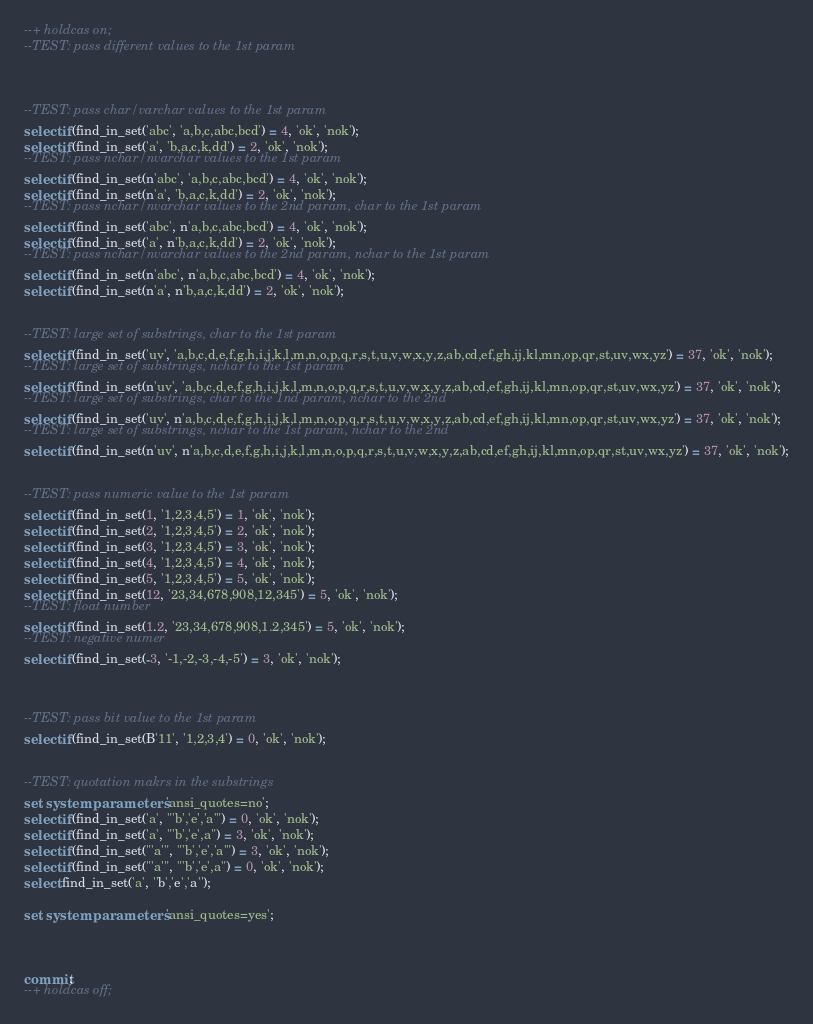Convert code to text. <code><loc_0><loc_0><loc_500><loc_500><_SQL_>--+ holdcas on;
--TEST: pass different values to the 1st param



--TEST: pass char/varchar values to the 1st param
select if(find_in_set('abc', 'a,b,c,abc,bcd') = 4, 'ok', 'nok');
select if(find_in_set('a', 'b,a,c,k,dd') = 2, 'ok', 'nok');
--TEST: pass nchar/nvarchar values to the 1st param
select if(find_in_set(n'abc', 'a,b,c,abc,bcd') = 4, 'ok', 'nok');
select if(find_in_set(n'a', 'b,a,c,k,dd') = 2, 'ok', 'nok');
--TEST: pass nchar/nvarchar values to the 2nd param, char to the 1st param
select if(find_in_set('abc', n'a,b,c,abc,bcd') = 4, 'ok', 'nok');
select if(find_in_set('a', n'b,a,c,k,dd') = 2, 'ok', 'nok');
--TEST: pass nchar/nvarchar values to the 2nd param, nchar to the 1st param
select if(find_in_set(n'abc', n'a,b,c,abc,bcd') = 4, 'ok', 'nok');
select if(find_in_set(n'a', n'b,a,c,k,dd') = 2, 'ok', 'nok');


--TEST: large set of substrings, char to the 1st param
select if(find_in_set('uv', 'a,b,c,d,e,f,g,h,i,j,k,l,m,n,o,p,q,r,s,t,u,v,w,x,y,z,ab,cd,ef,gh,ij,kl,mn,op,qr,st,uv,wx,yz') = 37, 'ok', 'nok');
--TEST: large set of substrings, nchar to the 1st param
select if(find_in_set(n'uv', 'a,b,c,d,e,f,g,h,i,j,k,l,m,n,o,p,q,r,s,t,u,v,w,x,y,z,ab,cd,ef,gh,ij,kl,mn,op,qr,st,uv,wx,yz') = 37, 'ok', 'nok');
--TEST: large set of substrings, char to the 1nd param, nchar to the 2nd
select if(find_in_set('uv', n'a,b,c,d,e,f,g,h,i,j,k,l,m,n,o,p,q,r,s,t,u,v,w,x,y,z,ab,cd,ef,gh,ij,kl,mn,op,qr,st,uv,wx,yz') = 37, 'ok', 'nok');
--TEST: large set of substrings, nchar to the 1st param, nchar to the 2nd
select if(find_in_set(n'uv', n'a,b,c,d,e,f,g,h,i,j,k,l,m,n,o,p,q,r,s,t,u,v,w,x,y,z,ab,cd,ef,gh,ij,kl,mn,op,qr,st,uv,wx,yz') = 37, 'ok', 'nok');


--TEST: pass numeric value to the 1st param
select if(find_in_set(1, '1,2,3,4,5') = 1, 'ok', 'nok');
select if(find_in_set(2, '1,2,3,4,5') = 2, 'ok', 'nok');
select if(find_in_set(3, '1,2,3,4,5') = 3, 'ok', 'nok');
select if(find_in_set(4, '1,2,3,4,5') = 4, 'ok', 'nok');
select if(find_in_set(5, '1,2,3,4,5') = 5, 'ok', 'nok');
select if(find_in_set(12, '23,34,678,908,12,345') = 5, 'ok', 'nok');
--TEST: float number
select if(find_in_set(1.2, '23,34,678,908,1.2,345') = 5, 'ok', 'nok');
--TEST: negative numer
select if(find_in_set(-3, '-1,-2,-3,-4,-5') = 3, 'ok', 'nok');



--TEST: pass bit value to the 1st param
select if(find_in_set(B'11', '1,2,3,4') = 0, 'ok', 'nok');


--TEST: quotation makrs in the substrings
set system parameters 'ansi_quotes=no';
select if(find_in_set('a', "'b','e','a'") = 0, 'ok', 'nok');
select if(find_in_set('a', "'b','e',a") = 3, 'ok', 'nok');
select if(find_in_set("'a'", "'b','e','a'") = 3, 'ok', 'nok');
select if(find_in_set("'a'", "'b','e',a") = 0, 'ok', 'nok');
select find_in_set('a', ''b','e','a'');

set system parameters 'ansi_quotes=yes';



commit;
--+ holdcas off;
</code> 